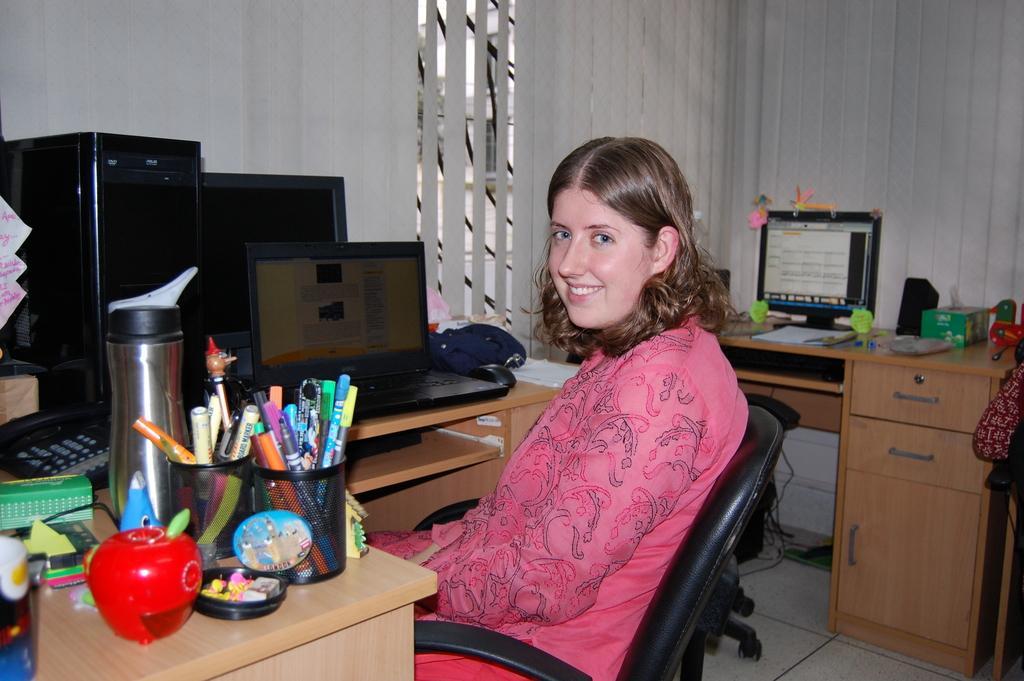Could you give a brief overview of what you see in this image? This picture describe about the inside view of the cabin in which one woman wearing pink t- shirt is watching towards the camera, On the table we can see the computer screen and pen holder, Behind a wooden table and computer screen with sticky notes and white blinds on the Glass window. 